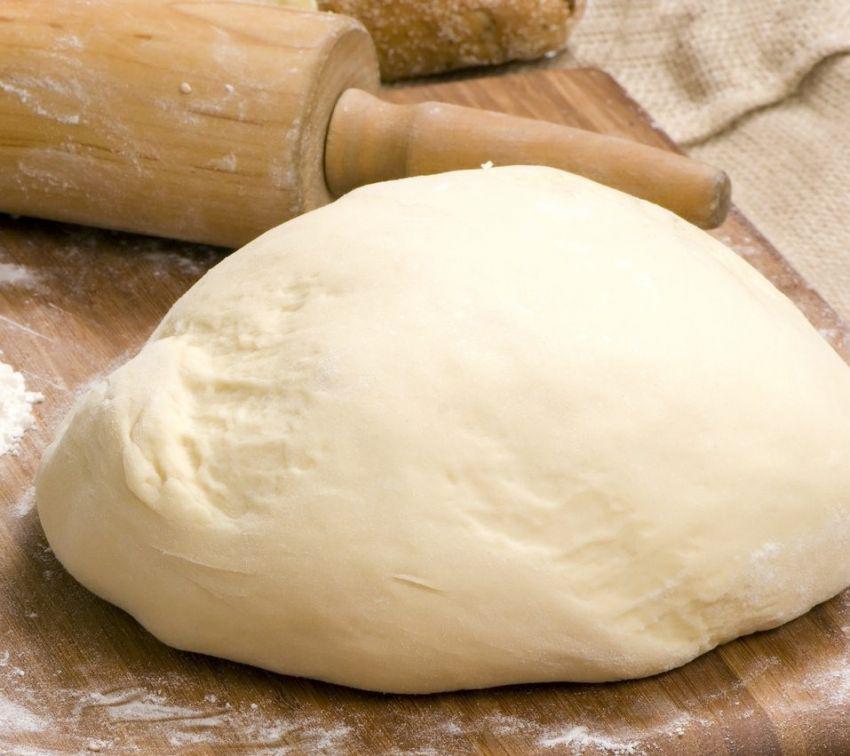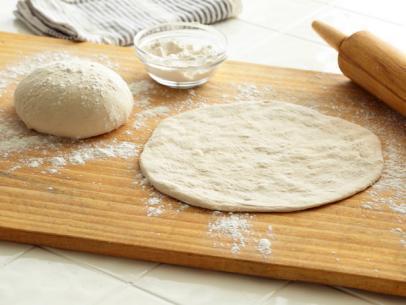The first image is the image on the left, the second image is the image on the right. For the images displayed, is the sentence "In one of the images there is a rolling pin." factually correct? Answer yes or no. Yes. The first image is the image on the left, the second image is the image on the right. Evaluate the accuracy of this statement regarding the images: "A wooden rolling pin is seen in the image on the left.". Is it true? Answer yes or no. Yes. 